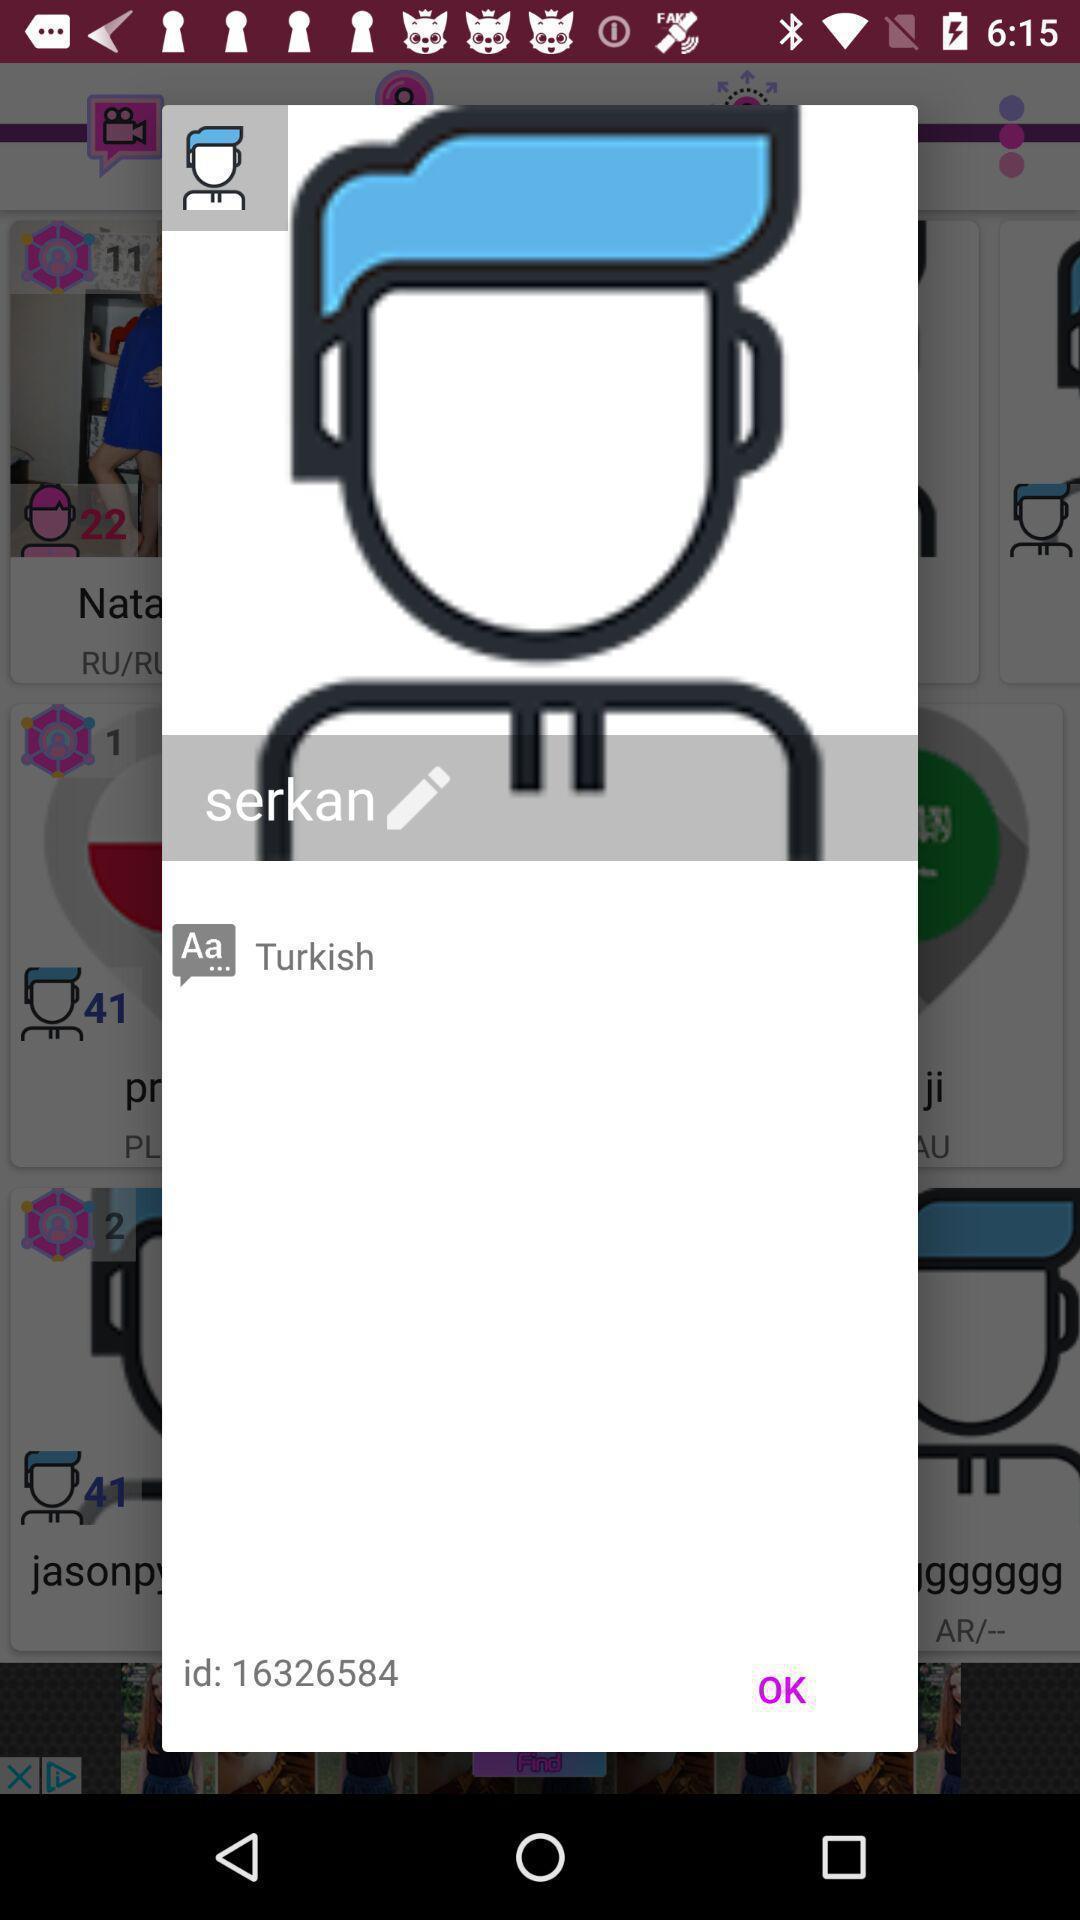Describe the visual elements of this screenshot. Pop-up showing the id with edit option. 